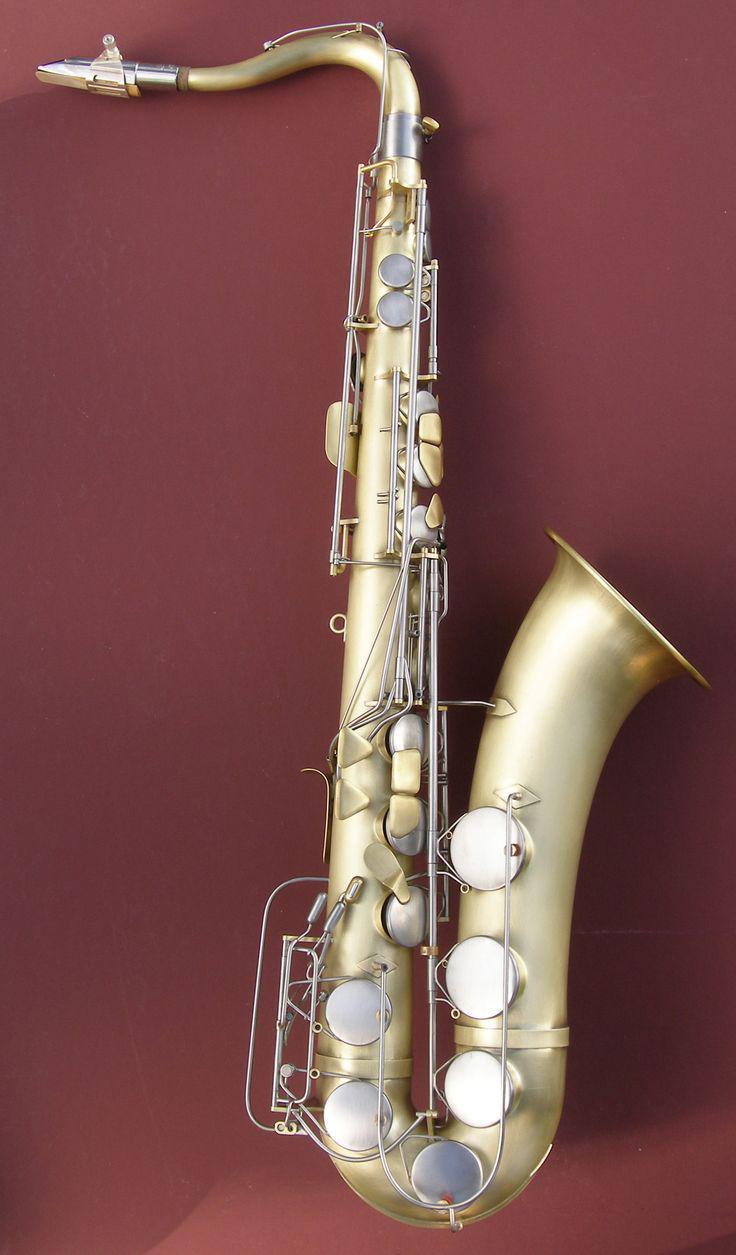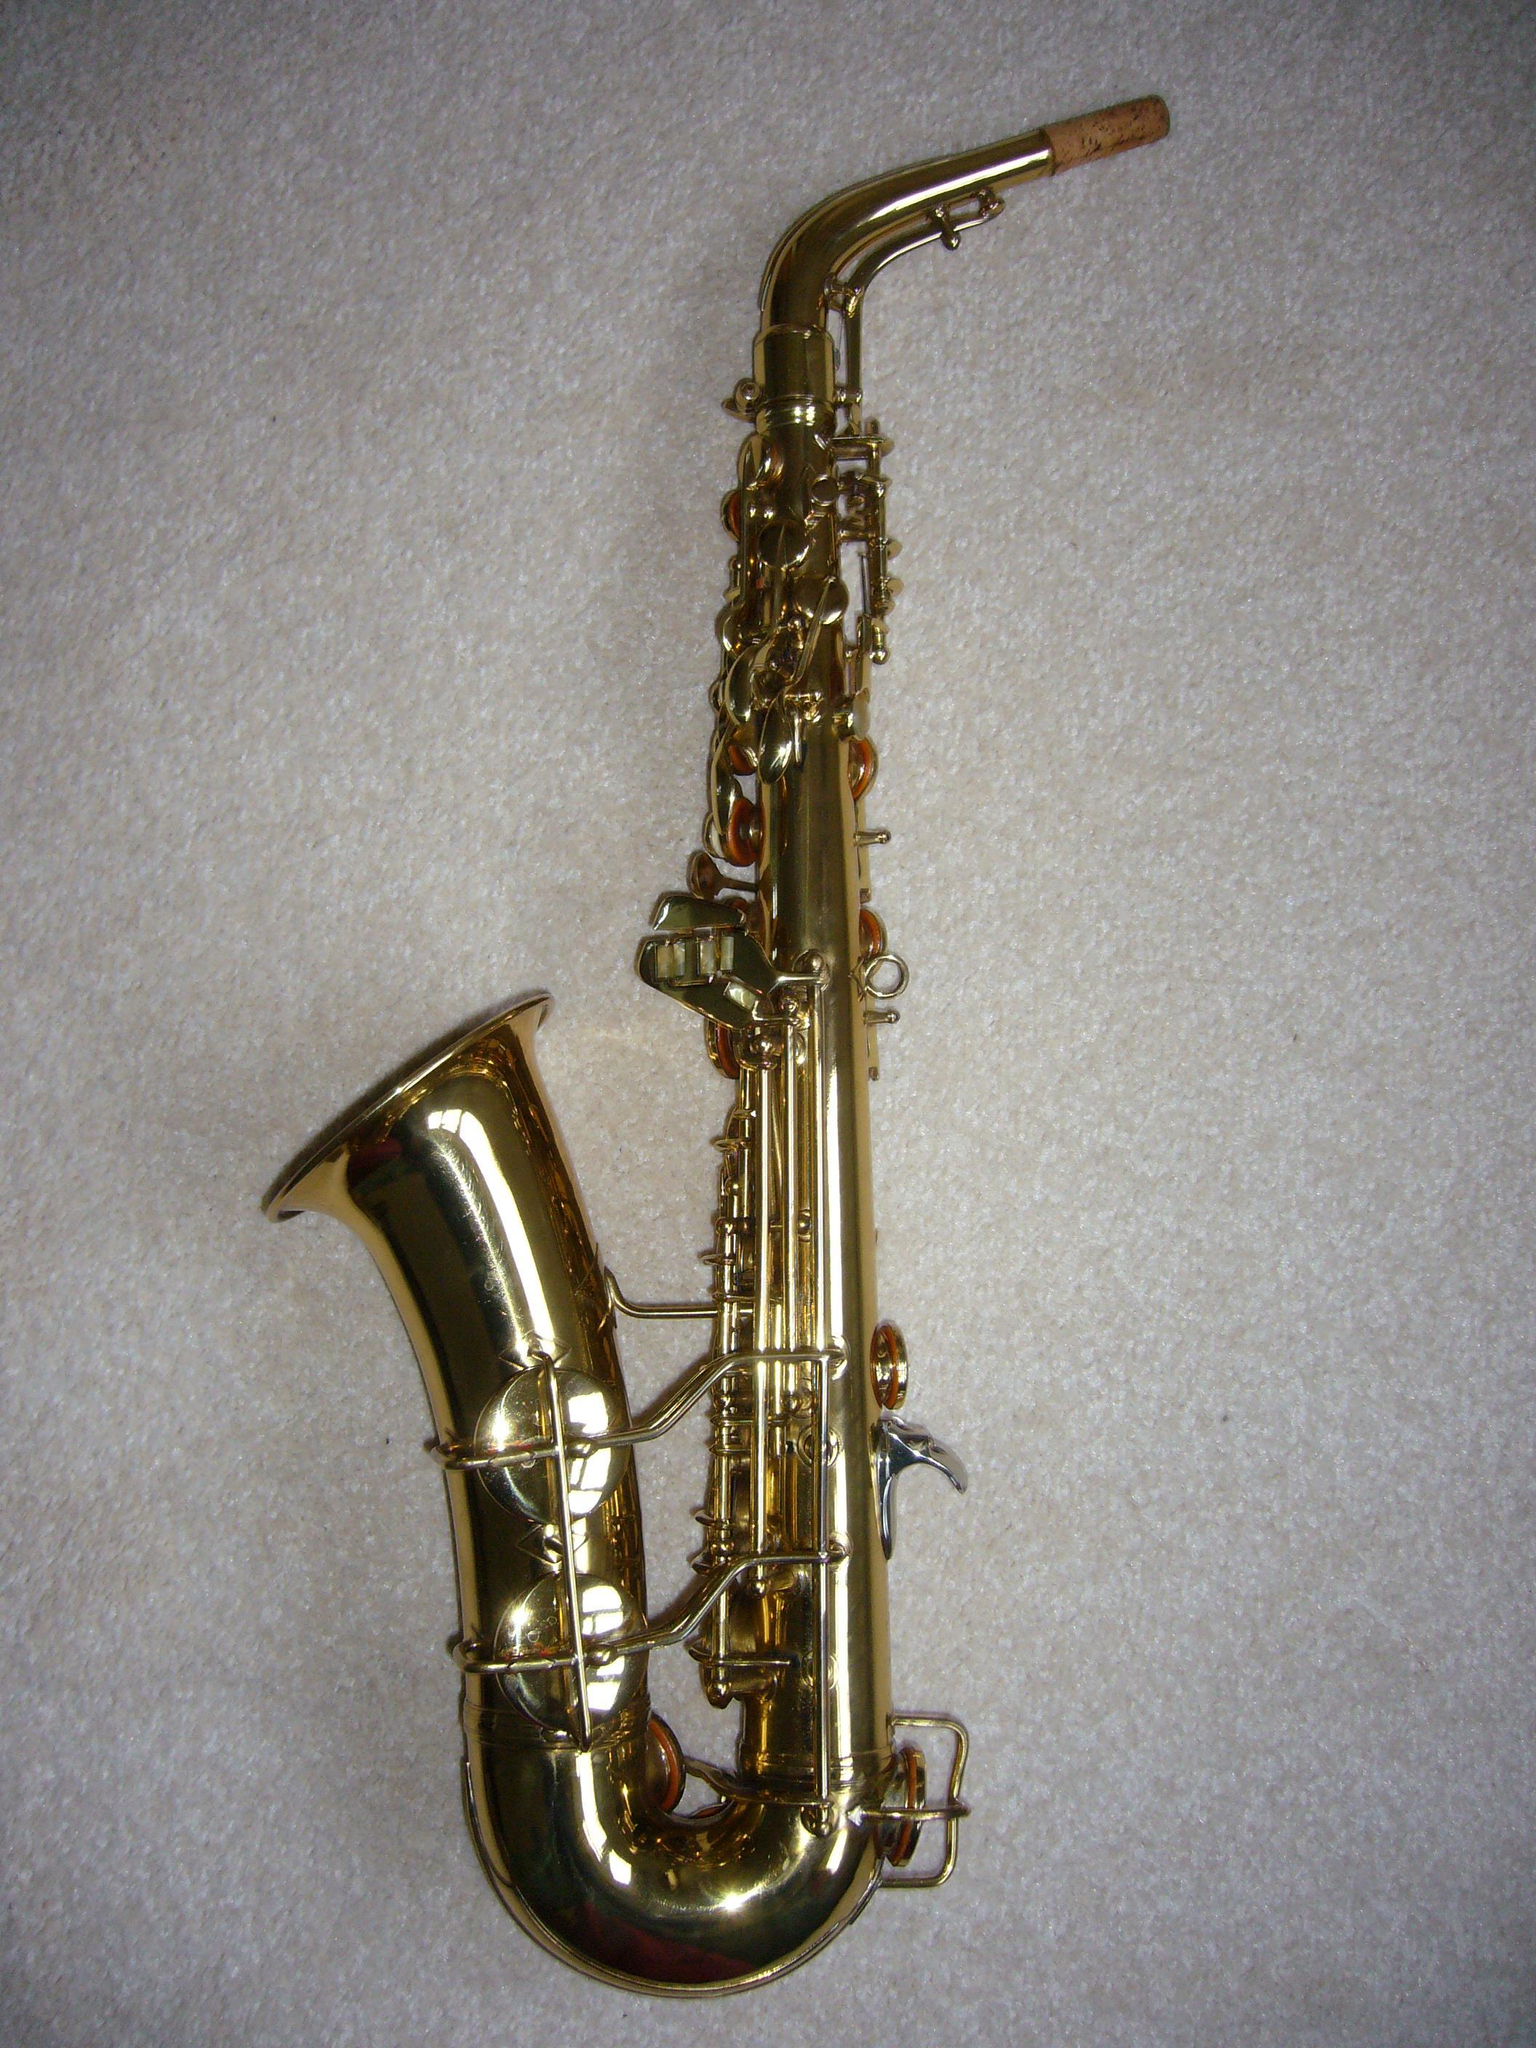The first image is the image on the left, the second image is the image on the right. Examine the images to the left and right. Is the description "All of the instruments are facing the same direction." accurate? Answer yes or no. No. The first image is the image on the left, the second image is the image on the right. For the images shown, is this caption "The image on the right has a solid black background." true? Answer yes or no. No. 